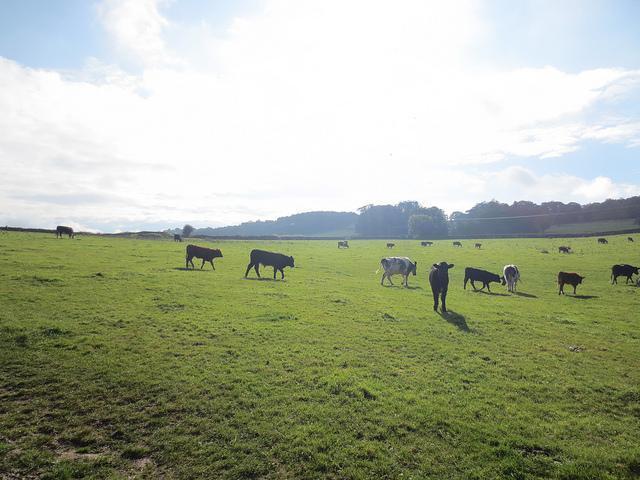How many dogs are in this photo?
Give a very brief answer. 0. 